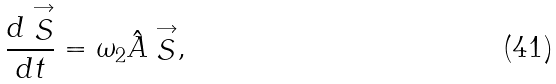Convert formula to latex. <formula><loc_0><loc_0><loc_500><loc_500>\frac { d \stackrel { \rightarrow } { S } } { d t } = \omega _ { 2 } \hat { A } \stackrel { \rightarrow } { S } ,</formula> 